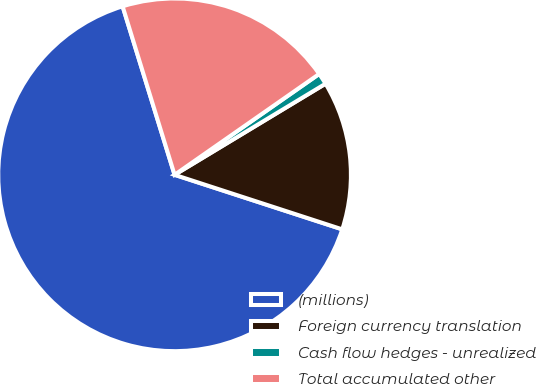Convert chart. <chart><loc_0><loc_0><loc_500><loc_500><pie_chart><fcel>(millions)<fcel>Foreign currency translation<fcel>Cash flow hedges - unrealized<fcel>Total accumulated other<nl><fcel>65.24%<fcel>13.65%<fcel>1.05%<fcel>20.07%<nl></chart> 